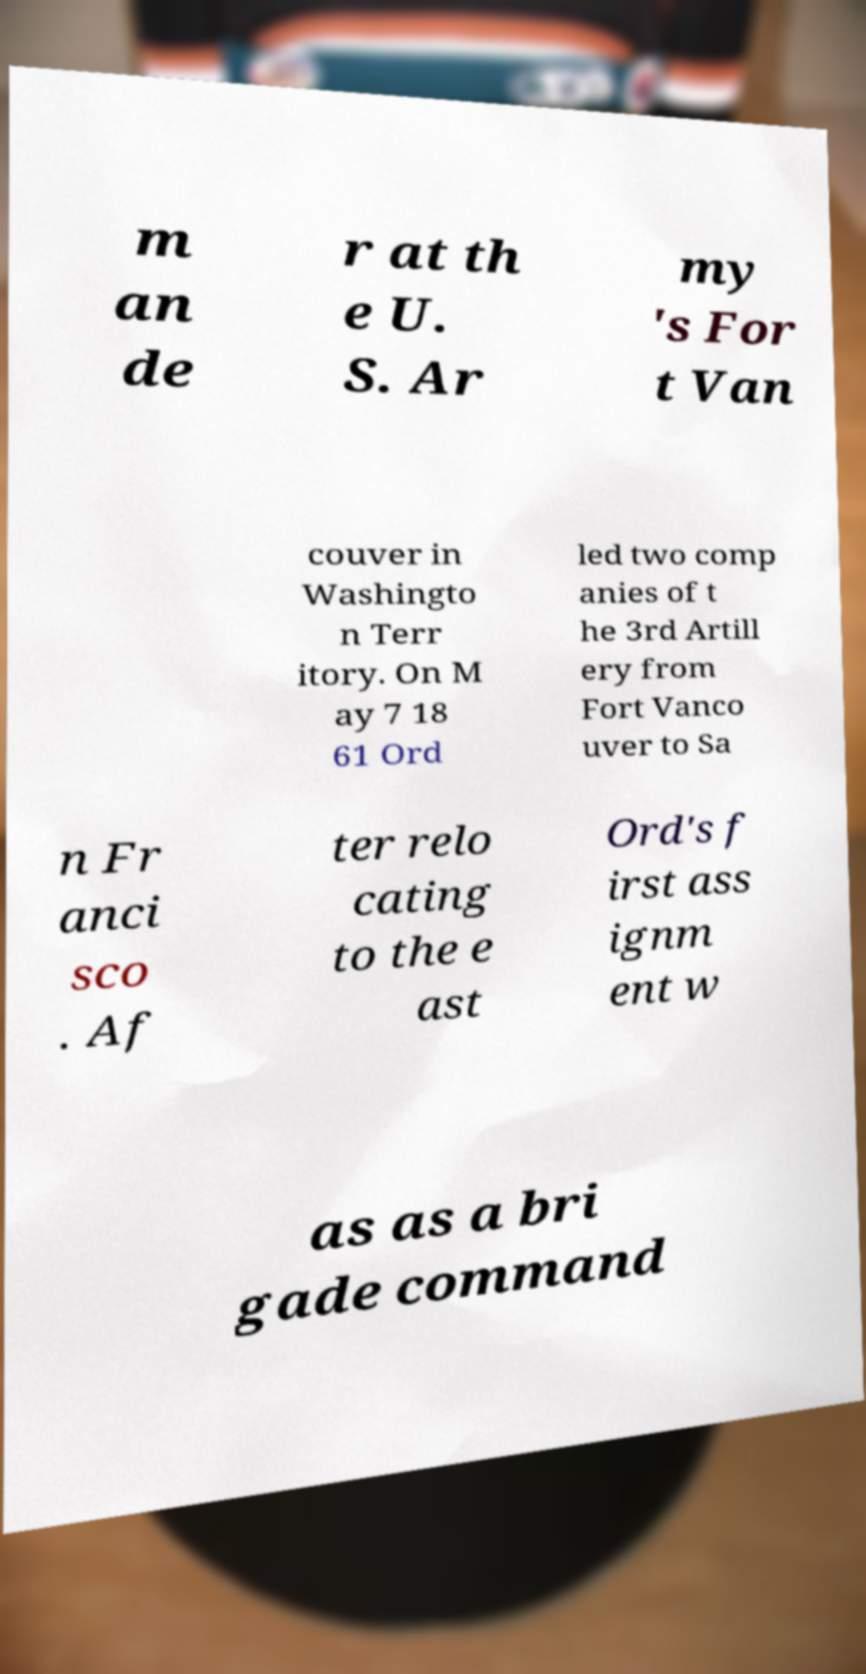What messages or text are displayed in this image? I need them in a readable, typed format. m an de r at th e U. S. Ar my 's For t Van couver in Washingto n Terr itory. On M ay 7 18 61 Ord led two comp anies of t he 3rd Artill ery from Fort Vanco uver to Sa n Fr anci sco . Af ter relo cating to the e ast Ord's f irst ass ignm ent w as as a bri gade command 